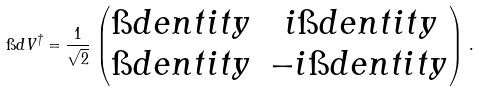Convert formula to latex. <formula><loc_0><loc_0><loc_500><loc_500>\i d V ^ { \dagger } = \frac { 1 } { \sqrt { 2 } } \, \begin{pmatrix} \i d e n t i t y & \, i \i d e n t i t y \\ \i d e n t i t y & - i \i d e n t i t y \end{pmatrix} \, .</formula> 